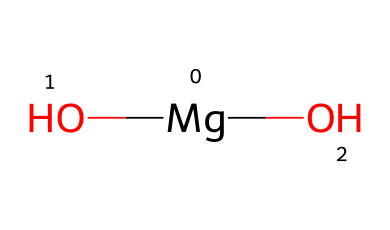What is the central atom in this chemical structure? The chemical structure shows one magnesium atom at its center, bonded to two hydroxide groups (OH). Therefore, the central atom is magnesium.
Answer: magnesium How many hydroxide groups are present in magnesium hydroxide? The SMILES representation shows that there are two hydroxide groups attached to the magnesium atom, indicated by the two (O) in the structure.
Answer: two What type of chemical compound is magnesium hydroxide? Magnesium hydroxide is classified as a base due to its ability to neutralize acids, which is characteristic of base compounds.
Answer: base What is the total number of atoms in magnesium hydroxide? The structure contains one magnesium atom and two oxygen atoms, each with one hydrogen atom in the hydroxide groups, resulting in a total of five atoms: one magnesium, two oxygens, and two hydrogens.
Answer: five What charge does magnesium carry in this compound? In the chemical structure, magnesium typically carries a +2 charge, which is common for alkaline earth metals when they form compounds.
Answer: +2 What is the primary use of magnesium hydroxide in vegan products? Magnesium hydroxide is primarily used as an antacid in vegan products to relieve heartburn and indigestion without any animal-derived ingredients.
Answer: antacid How does the presence of hydroxide groups influence the solubility of magnesium hydroxide? The hydroxide groups contribute to the chemical's basicity and help to determine its limited solubility in water, as bases generally have lower solubility compared to acids.
Answer: limited solubility 